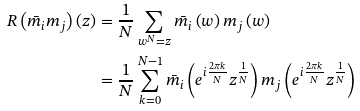<formula> <loc_0><loc_0><loc_500><loc_500>R \left ( \bar { m } _ { i } m _ { j } \right ) \left ( z \right ) & = \frac { 1 } { N } \sum _ { w ^ { N } = z } \bar { m } _ { i } \left ( w \right ) m _ { j } \left ( w \right ) \\ & = \frac { 1 } { N } \sum _ { k = 0 } ^ { N - 1 } \bar { m } _ { i } \left ( e ^ { i \frac { 2 \pi k } { N } } z ^ { \frac { 1 } { N } } \right ) m _ { j } \left ( e ^ { i \frac { 2 \pi k } { N } } z ^ { \frac { 1 } { N } } \right )</formula> 